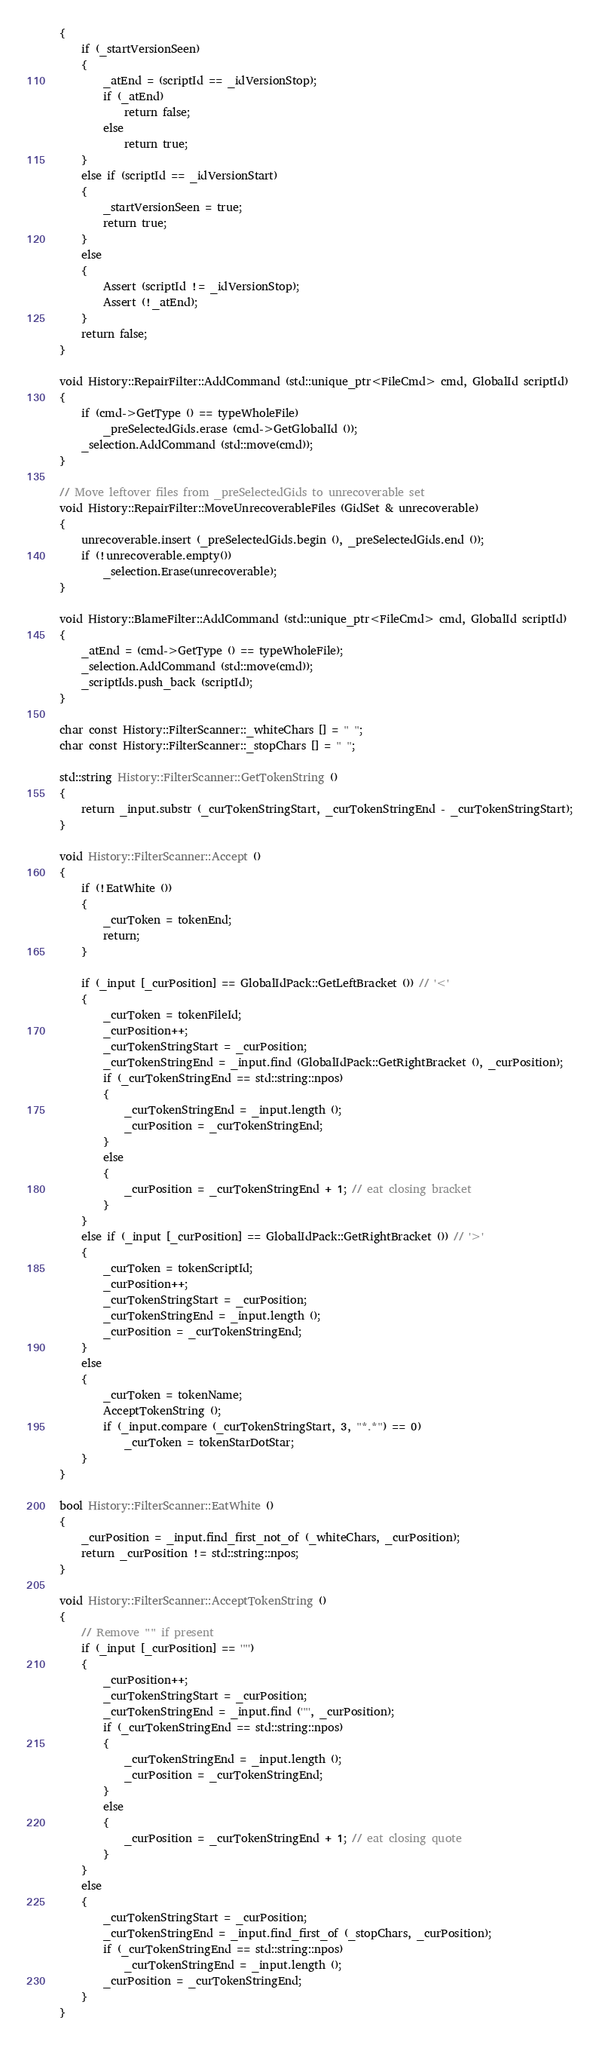<code> <loc_0><loc_0><loc_500><loc_500><_C++_>{
	if (_startVersionSeen)
	{
		_atEnd = (scriptId == _idVersionStop);
		if (_atEnd)
			return false;
		else
			return true;
	}
	else if (scriptId == _idVersionStart)
	{
		_startVersionSeen = true;
		return true;
	}
	else
	{
		Assert (scriptId != _idVersionStop);
		Assert (!_atEnd);
	}
	return false;
}

void History::RepairFilter::AddCommand (std::unique_ptr<FileCmd> cmd, GlobalId scriptId)
{
	if (cmd->GetType () == typeWholeFile)
		_preSelectedGids.erase (cmd->GetGlobalId ());
	_selection.AddCommand (std::move(cmd));
}

// Move leftover files from _preSelectedGids to unrecoverable set
void History::RepairFilter::MoveUnrecoverableFiles (GidSet & unrecoverable)
{
	unrecoverable.insert (_preSelectedGids.begin (), _preSelectedGids.end ());
	if (!unrecoverable.empty())
		_selection.Erase(unrecoverable);
}

void History::BlameFilter::AddCommand (std::unique_ptr<FileCmd> cmd, GlobalId scriptId)
{
	_atEnd = (cmd->GetType () == typeWholeFile);
	_selection.AddCommand (std::move(cmd));
	_scriptIds.push_back (scriptId);
}

char const History::FilterScanner::_whiteChars [] = " ";
char const History::FilterScanner::_stopChars [] = " ";

std::string History::FilterScanner::GetTokenString ()
{
	return _input.substr (_curTokenStringStart, _curTokenStringEnd - _curTokenStringStart);
}

void History::FilterScanner::Accept ()
{
	if (!EatWhite ())
	{
		_curToken = tokenEnd;
		return;
	}

	if (_input [_curPosition] == GlobalIdPack::GetLeftBracket ()) // '<'
	{
		_curToken = tokenFileId;
		_curPosition++;
		_curTokenStringStart = _curPosition;
		_curTokenStringEnd = _input.find (GlobalIdPack::GetRightBracket (), _curPosition);
		if (_curTokenStringEnd == std::string::npos)
		{
			_curTokenStringEnd = _input.length ();
			_curPosition = _curTokenStringEnd;
		}
		else
		{
			_curPosition = _curTokenStringEnd + 1; // eat closing bracket
		}
	}
	else if (_input [_curPosition] == GlobalIdPack::GetRightBracket ()) // '>'
	{
		_curToken = tokenScriptId;
		_curPosition++;
		_curTokenStringStart = _curPosition;
		_curTokenStringEnd = _input.length ();
		_curPosition = _curTokenStringEnd;
	}
	else
	{
		_curToken = tokenName;
		AcceptTokenString ();
		if (_input.compare (_curTokenStringStart, 3, "*.*") == 0)
			_curToken = tokenStarDotStar;
	}
}

bool History::FilterScanner::EatWhite ()
{
	_curPosition = _input.find_first_not_of (_whiteChars, _curPosition);
	return _curPosition != std::string::npos;
}

void History::FilterScanner::AcceptTokenString ()
{
	// Remove "" if present
	if (_input [_curPosition] == '"')
	{
		_curPosition++;
		_curTokenStringStart = _curPosition;
		_curTokenStringEnd = _input.find ('"', _curPosition);
		if (_curTokenStringEnd == std::string::npos)
		{
			_curTokenStringEnd = _input.length ();
			_curPosition = _curTokenStringEnd;
		}
		else
		{
			_curPosition = _curTokenStringEnd + 1; // eat closing quote
		}
	}
	else
	{
		_curTokenStringStart = _curPosition;
		_curTokenStringEnd = _input.find_first_of (_stopChars, _curPosition);
		if (_curTokenStringEnd == std::string::npos)
			_curTokenStringEnd = _input.length ();
		_curPosition = _curTokenStringEnd;
	}
}
</code> 